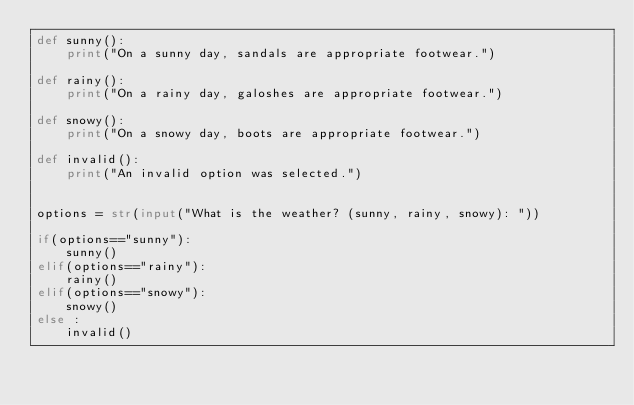Convert code to text. <code><loc_0><loc_0><loc_500><loc_500><_Python_>def sunny():
    print("On a sunny day, sandals are appropriate footwear.")

def rainy():
    print("On a rainy day, galoshes are appropriate footwear.")

def snowy():
    print("On a snowy day, boots are appropriate footwear.")

def invalid():
    print("An invalid option was selected.")


options = str(input("What is the weather? (sunny, rainy, snowy): "))

if(options=="sunny"):
    sunny()
elif(options=="rainy"):
    rainy()
elif(options=="snowy"):
    snowy()
else :
    invalid()
</code> 